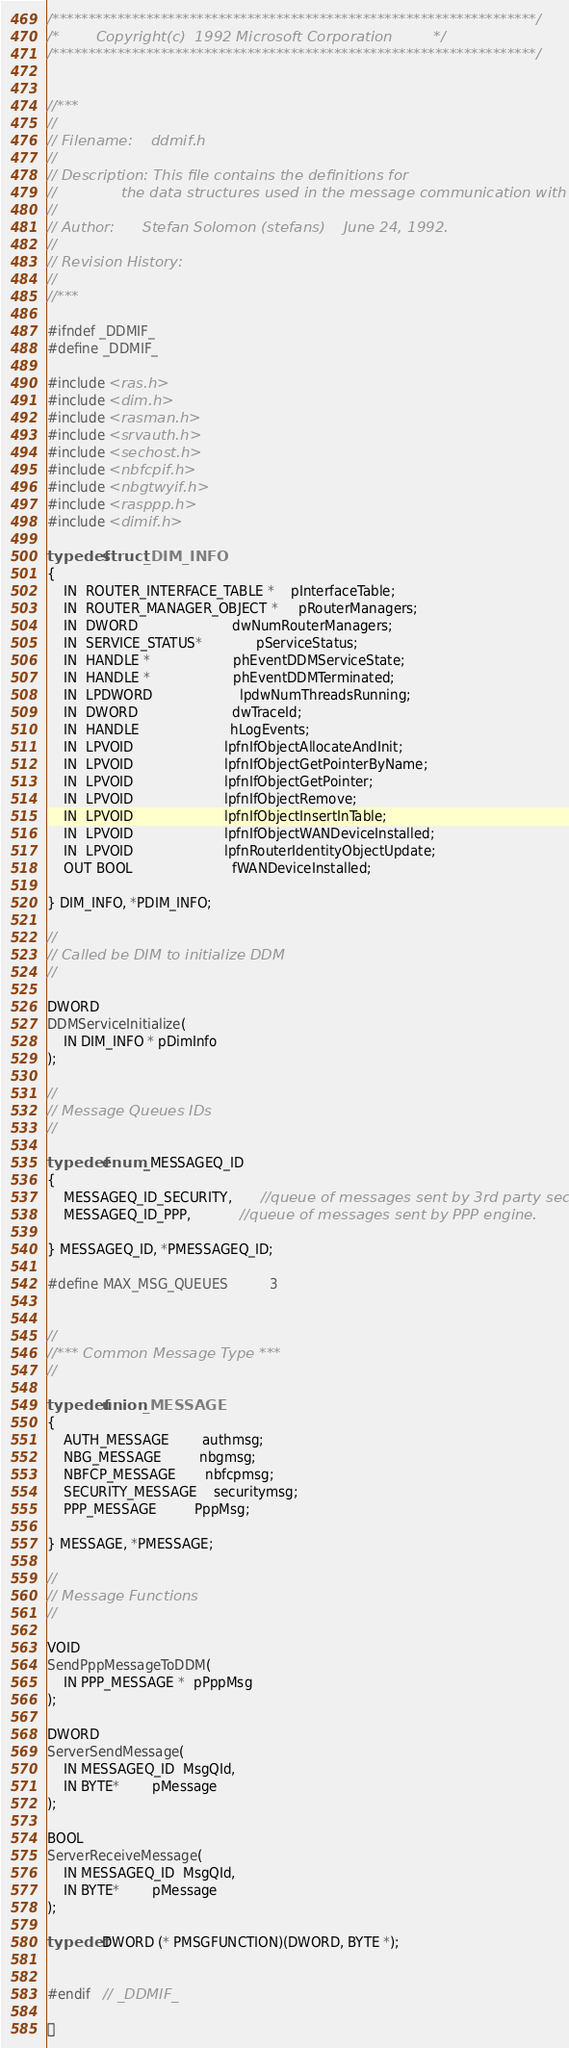Convert code to text. <code><loc_0><loc_0><loc_500><loc_500><_C_>/*******************************************************************/
/*	      Copyright(c)  1992 Microsoft Corporation		   */
/*******************************************************************/


//***
//
// Filename:	ddmif.h
//
// Description: This file contains the definitions for
//		        the data structures used in the message communication with DDM.
//
// Author:	    Stefan Solomon (stefans)    June 24, 1992.
//
// Revision History:
//
//***

#ifndef _DDMIF_
#define _DDMIF_

#include <ras.h>
#include <dim.h>
#include <rasman.h>
#include <srvauth.h>
#include <sechost.h>
#include <nbfcpif.h>
#include <nbgtwyif.h>
#include <rasppp.h>
#include <dimif.h>

typedef struct _DIM_INFO
{
    IN  ROUTER_INTERFACE_TABLE *    pInterfaceTable;
    IN  ROUTER_MANAGER_OBJECT *     pRouterManagers;
    IN  DWORD                       dwNumRouterManagers;
    IN  SERVICE_STATUS*             pServiceStatus;
    IN  HANDLE *                    phEventDDMServiceState;
    IN  HANDLE *                    phEventDDMTerminated;
    IN  LPDWORD                     lpdwNumThreadsRunning;
    IN  DWORD                       dwTraceId;
    IN  HANDLE                      hLogEvents;
    IN  LPVOID                      lpfnIfObjectAllocateAndInit;
    IN  LPVOID                      lpfnIfObjectGetPointerByName;
    IN  LPVOID                      lpfnIfObjectGetPointer;
    IN  LPVOID                      lpfnIfObjectRemove;
    IN  LPVOID                      lpfnIfObjectInsertInTable;
    IN  LPVOID                      lpfnIfObjectWANDeviceInstalled;
    IN  LPVOID                      lpfnRouterIdentityObjectUpdate;
    OUT BOOL                        fWANDeviceInstalled;

} DIM_INFO, *PDIM_INFO;

//
// Called be DIM to initialize DDM
//

DWORD
DDMServiceInitialize(
    IN DIM_INFO * pDimInfo
);

//
// Message Queues IDs
//

typedef enum _MESSAGEQ_ID
{
    MESSAGEQ_ID_SECURITY,       //queue of messages sent by 3rd party sec.dll
    MESSAGEQ_ID_PPP,            //queue of messages sent by PPP engine.

} MESSAGEQ_ID, *PMESSAGEQ_ID;

#define MAX_MSG_QUEUES          3


//
//*** Common Message Type ***
//

typedef union _MESSAGE
{
    AUTH_MESSAGE        authmsg;
    NBG_MESSAGE         nbgmsg;
    NBFCP_MESSAGE       nbfcpmsg;
    SECURITY_MESSAGE    securitymsg;
    PPP_MESSAGE         PppMsg;

} MESSAGE, *PMESSAGE;

//
// Message Functions
//

VOID
SendPppMessageToDDM(
    IN PPP_MESSAGE *  pPppMsg
);

DWORD
ServerSendMessage(
    IN MESSAGEQ_ID  MsgQId,
    IN BYTE*        pMessage
);

BOOL
ServerReceiveMessage(
    IN MESSAGEQ_ID  MsgQId,
    IN BYTE*        pMessage
);

typedef DWORD (* PMSGFUNCTION)(DWORD, BYTE *);


#endif   // _DDMIF_


</code> 